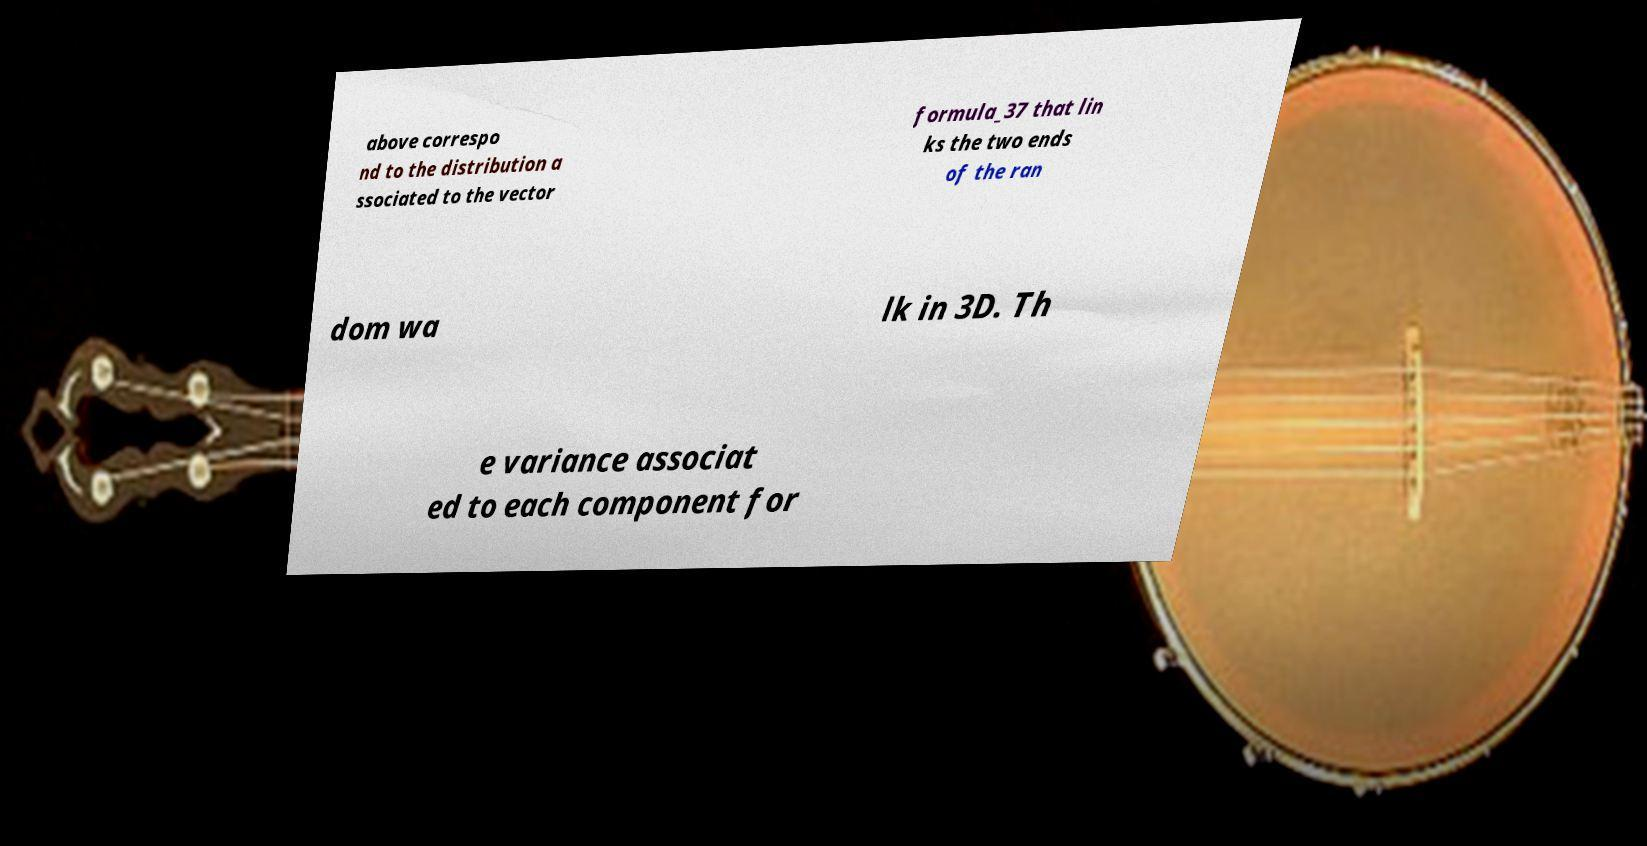For documentation purposes, I need the text within this image transcribed. Could you provide that? above correspo nd to the distribution a ssociated to the vector formula_37 that lin ks the two ends of the ran dom wa lk in 3D. Th e variance associat ed to each component for 